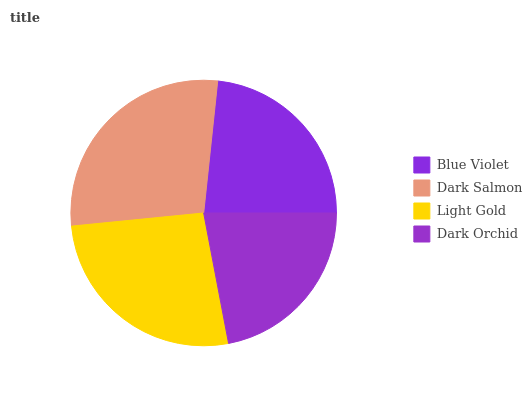Is Dark Orchid the minimum?
Answer yes or no. Yes. Is Dark Salmon the maximum?
Answer yes or no. Yes. Is Light Gold the minimum?
Answer yes or no. No. Is Light Gold the maximum?
Answer yes or no. No. Is Dark Salmon greater than Light Gold?
Answer yes or no. Yes. Is Light Gold less than Dark Salmon?
Answer yes or no. Yes. Is Light Gold greater than Dark Salmon?
Answer yes or no. No. Is Dark Salmon less than Light Gold?
Answer yes or no. No. Is Light Gold the high median?
Answer yes or no. Yes. Is Blue Violet the low median?
Answer yes or no. Yes. Is Blue Violet the high median?
Answer yes or no. No. Is Light Gold the low median?
Answer yes or no. No. 